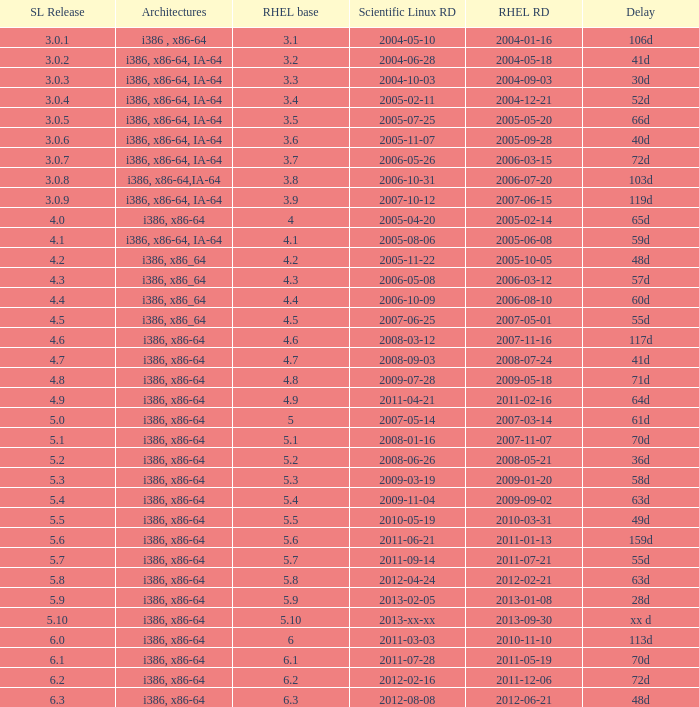Name the scientific linux release when delay is 28d 5.9. 